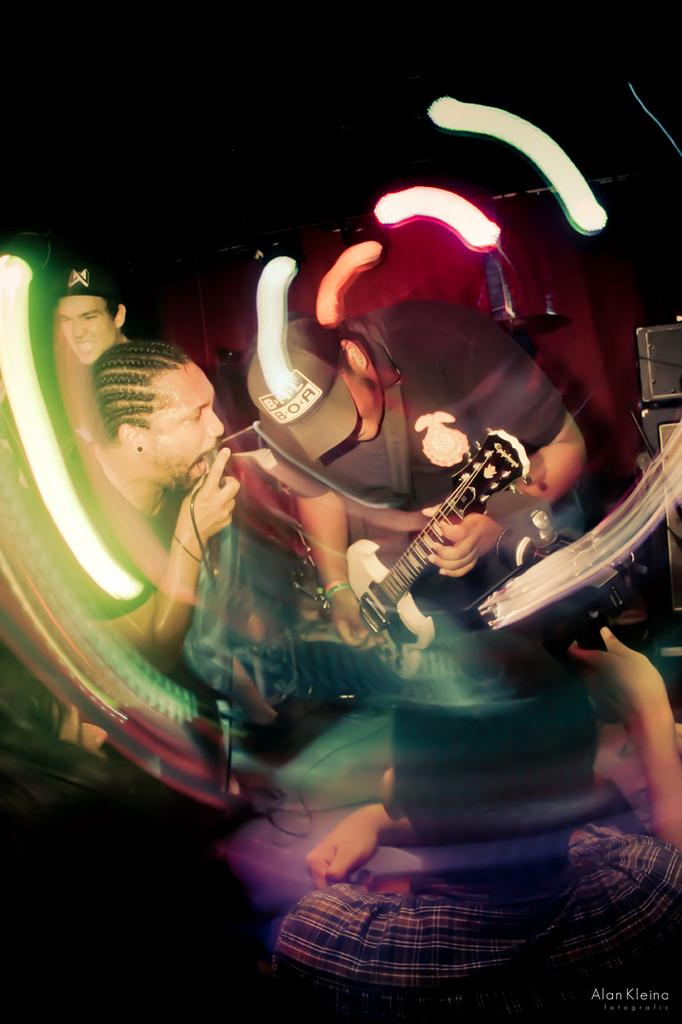What is happening in the image? There is a group of musicians in the image, and they are performing. Can you describe the musicians in the image? Unfortunately, the facts provided do not give any details about the musicians' appearance or instruments. What might be the purpose of the musicians' performance? The purpose of the musicians' performance is not specified in the facts provided. What type of mailbox can be seen in the image? There is no mailbox present in the image; it features a group of musicians performing. 